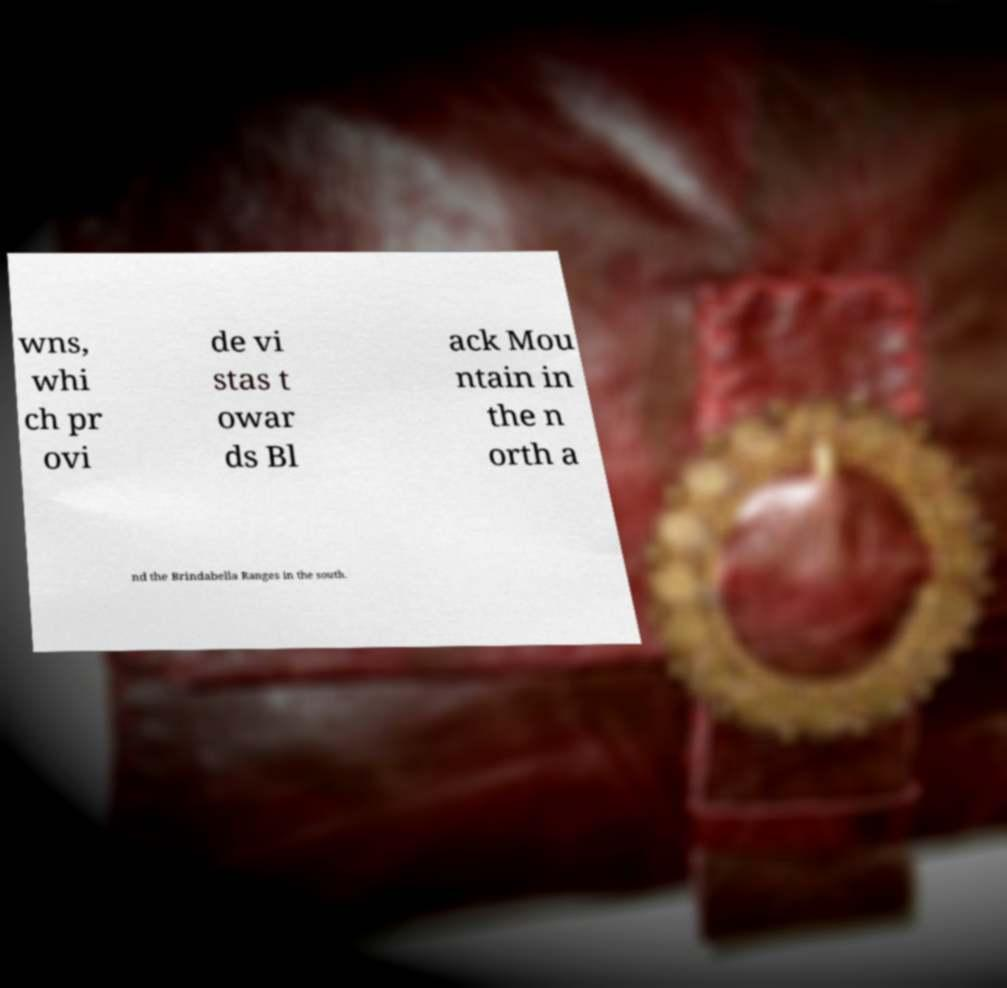Can you accurately transcribe the text from the provided image for me? wns, whi ch pr ovi de vi stas t owar ds Bl ack Mou ntain in the n orth a nd the Brindabella Ranges in the south. 